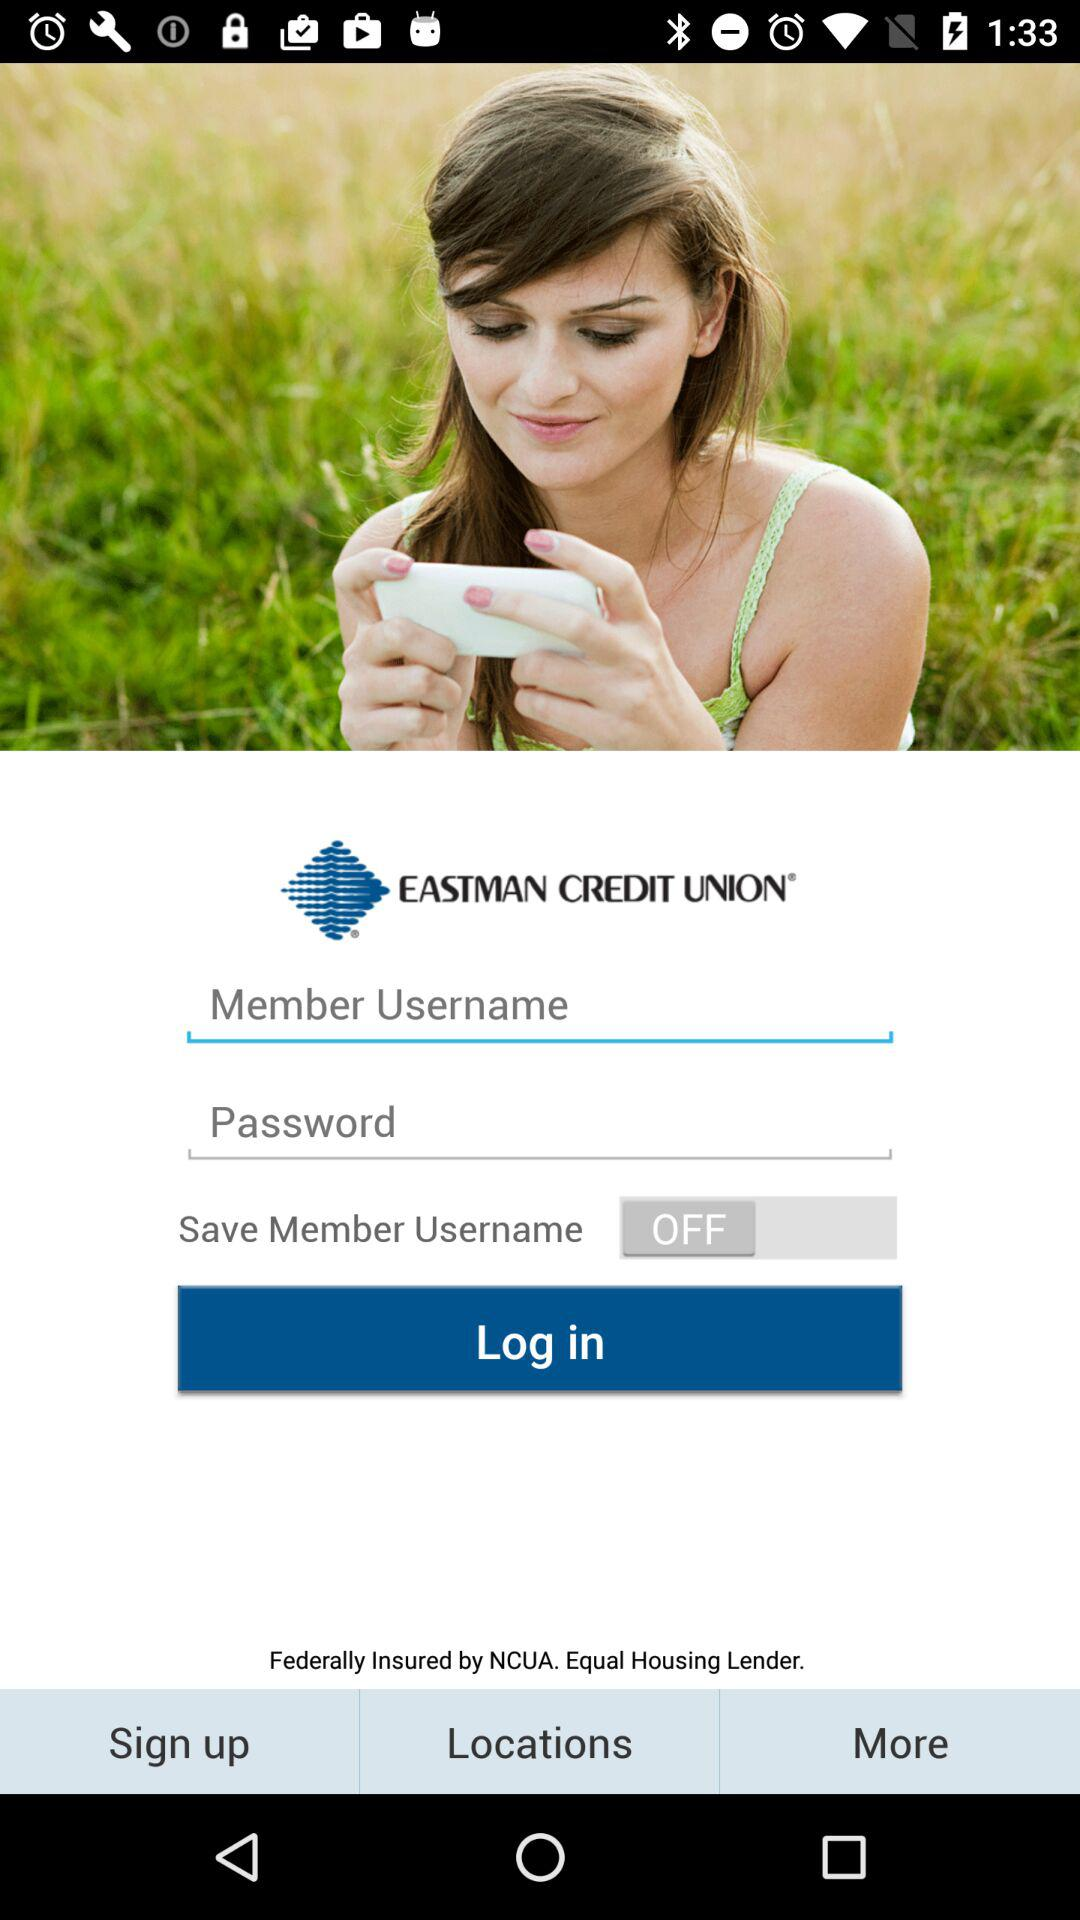Where is the nearest credit union location?
When the provided information is insufficient, respond with <no answer>. <no answer> 